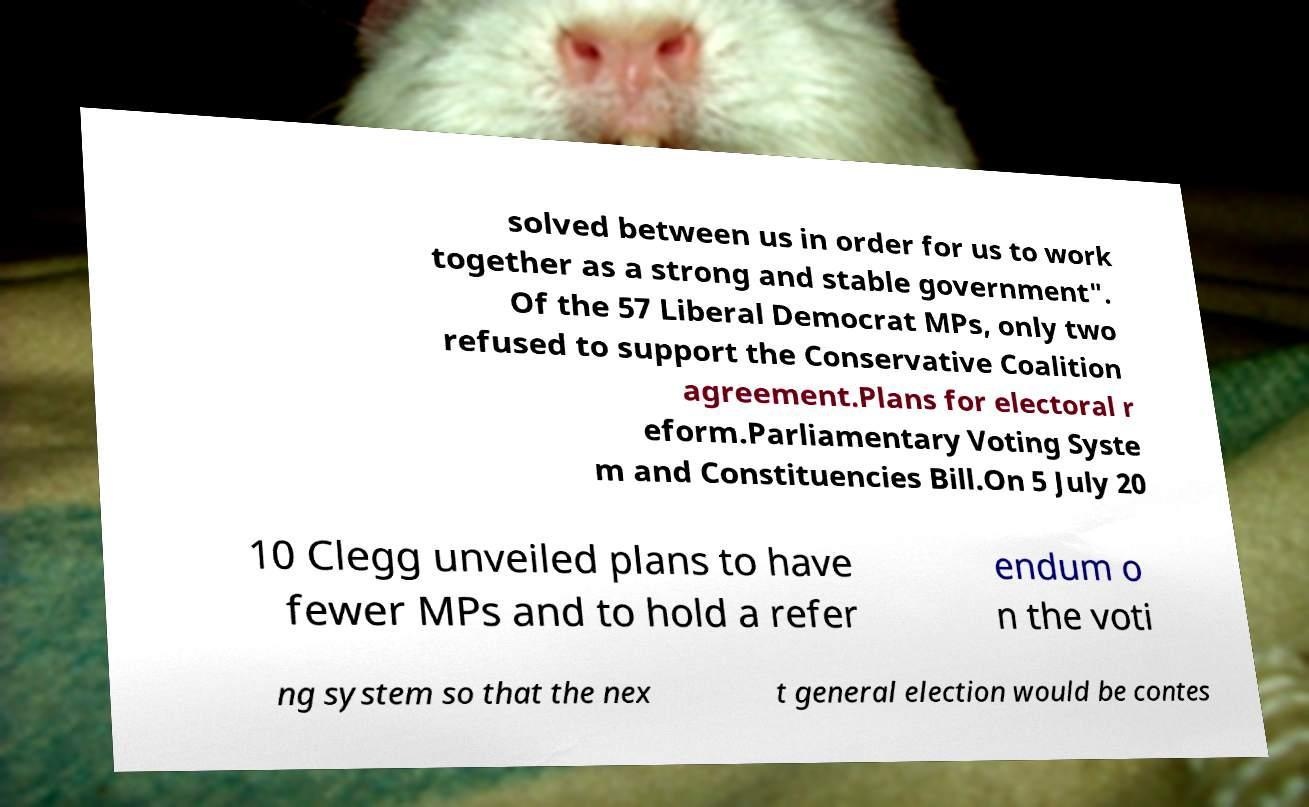Can you accurately transcribe the text from the provided image for me? solved between us in order for us to work together as a strong and stable government". Of the 57 Liberal Democrat MPs, only two refused to support the Conservative Coalition agreement.Plans for electoral r eform.Parliamentary Voting Syste m and Constituencies Bill.On 5 July 20 10 Clegg unveiled plans to have fewer MPs and to hold a refer endum o n the voti ng system so that the nex t general election would be contes 